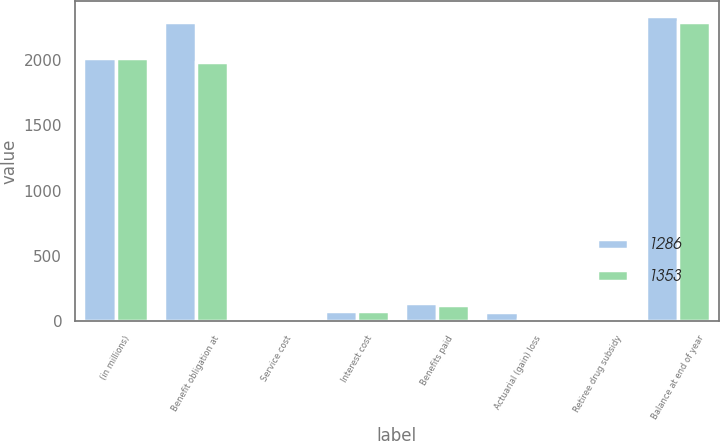Convert chart to OTSL. <chart><loc_0><loc_0><loc_500><loc_500><stacked_bar_chart><ecel><fcel>(in millions)<fcel>Benefit obligation at<fcel>Service cost<fcel>Interest cost<fcel>Benefits paid<fcel>Actuarial (gain) loss<fcel>Retiree drug subsidy<fcel>Balance at end of year<nl><fcel>1286<fcel>2017<fcel>2297<fcel>24<fcel>79<fcel>136<fcel>65<fcel>7<fcel>2339<nl><fcel>1353<fcel>2016<fcel>1989<fcel>22<fcel>76<fcel>119<fcel>16<fcel>7<fcel>2297<nl></chart> 